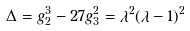<formula> <loc_0><loc_0><loc_500><loc_500>\Delta = g _ { 2 } ^ { 3 } - 2 7 g _ { 3 } ^ { 2 } = \lambda ^ { 2 } ( \lambda - 1 ) ^ { 2 }</formula> 